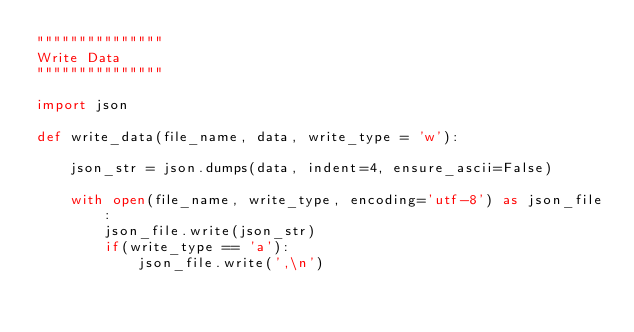Convert code to text. <code><loc_0><loc_0><loc_500><loc_500><_Python_>"""""""""""""""
Write Data
"""""""""""""""

import json

def write_data(file_name, data, write_type = 'w'):

    json_str = json.dumps(data, indent=4, ensure_ascii=False)

    with open(file_name, write_type, encoding='utf-8') as json_file:
        json_file.write(json_str)
        if(write_type == 'a'):
            json_file.write(',\n')
            </code> 